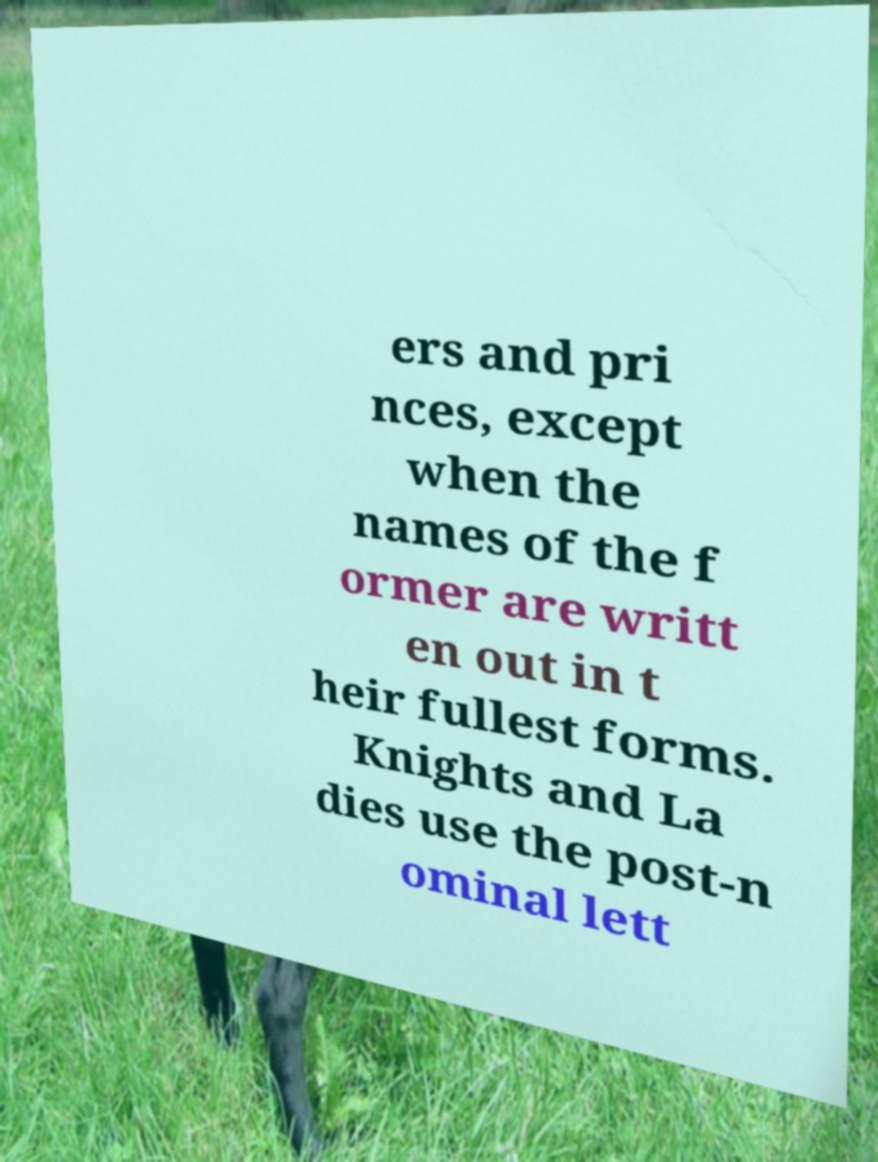There's text embedded in this image that I need extracted. Can you transcribe it verbatim? ers and pri nces, except when the names of the f ormer are writt en out in t heir fullest forms. Knights and La dies use the post-n ominal lett 